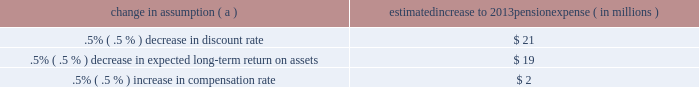Securities have historically returned approximately 10% ( 10 % ) annually over long periods of time , while u.s .
Debt securities have returned approximately 6% ( 6 % ) annually over long periods .
Application of these historical returns to the plan 2019s allocation ranges for equities and bonds produces a result between 7.25% ( 7.25 % ) and 8.75% ( 8.75 % ) and is one point of reference , among many other factors , that is taken into consideration .
We also examine the plan 2019s actual historical returns over various periods and consider the current economic environment .
Recent experience is considered in our evaluation with appropriate consideration that , especially for short time periods , recent returns are not reliable indicators of future returns .
While annual returns can vary significantly ( actual returns for 2012 , 2011 , and 2010 were +15.29% ( +15.29 % ) , +.11% ( +.11 % ) , and +14.87% ( +14.87 % ) , respectively ) , the selected assumption represents our estimated long-term average prospective returns .
Acknowledging the potentially wide range for this assumption , we also annually examine the assumption used by other companies with similar pension investment strategies , so that we can ascertain whether our determinations markedly differ from others .
In all cases , however , this data simply informs our process , which places the greatest emphasis on our qualitative judgment of future investment returns , given the conditions existing at each annual measurement date .
Taking into consideration all of these factors , the expected long-term return on plan assets for determining net periodic pension cost for 2012 was 7.75% ( 7.75 % ) , the same as it was for 2011 .
After considering the views of both internal and external capital market advisors , particularly with regard to the effects of the recent economic environment on long-term prospective fixed income returns , we are reducing our expected long-term return on assets to 7.50% ( 7.50 % ) for determining pension cost for under current accounting rules , the difference between expected long-term returns and actual returns is accumulated and amortized to pension expense over future periods .
Each one percentage point difference in actual return compared with our expected return causes expense in subsequent years to increase or decrease by up to $ 8 million as the impact is amortized into results of operations .
We currently estimate a pretax pension expense of $ 73 million in 2013 compared with pretax expense of $ 89 million in 2012 .
This year-over-year expected decrease reflects the impact of favorable returns on plan assets experienced in 2012 as well as the effects of the lower discount rate required to be used in the table below reflects the estimated effects on pension expense of certain changes in annual assumptions , using 2013 estimated expense as a baseline .
Table 27 : pension expense - sensitivity analysis change in assumption ( a ) estimated increase to 2013 pension expense ( in millions ) .
( a ) the impact is the effect of changing the specified assumption while holding all other assumptions constant .
Our pension plan contribution requirements are not particularly sensitive to actuarial assumptions .
Investment performance has the most impact on contribution requirements and will drive the amount of required contributions in future years .
Also , current law , including the provisions of the pension protection act of 2006 , sets limits as to both minimum and maximum contributions to the plan .
We do not expect to be required by law to make any contributions to the plan during 2013 .
We maintain other defined benefit plans that have a less significant effect on financial results , including various nonqualified supplemental retirement plans for certain employees , which are described more fully in note 15 employee benefit plans in the notes to consolidated financial statements in item 8 of this report .
The pnc financial services group , inc .
2013 form 10-k 77 .
What is average estimated pretax pension expense for 2013 and 2012? 
Computations: ((73 + 89) / 2)
Answer: 81.0. 